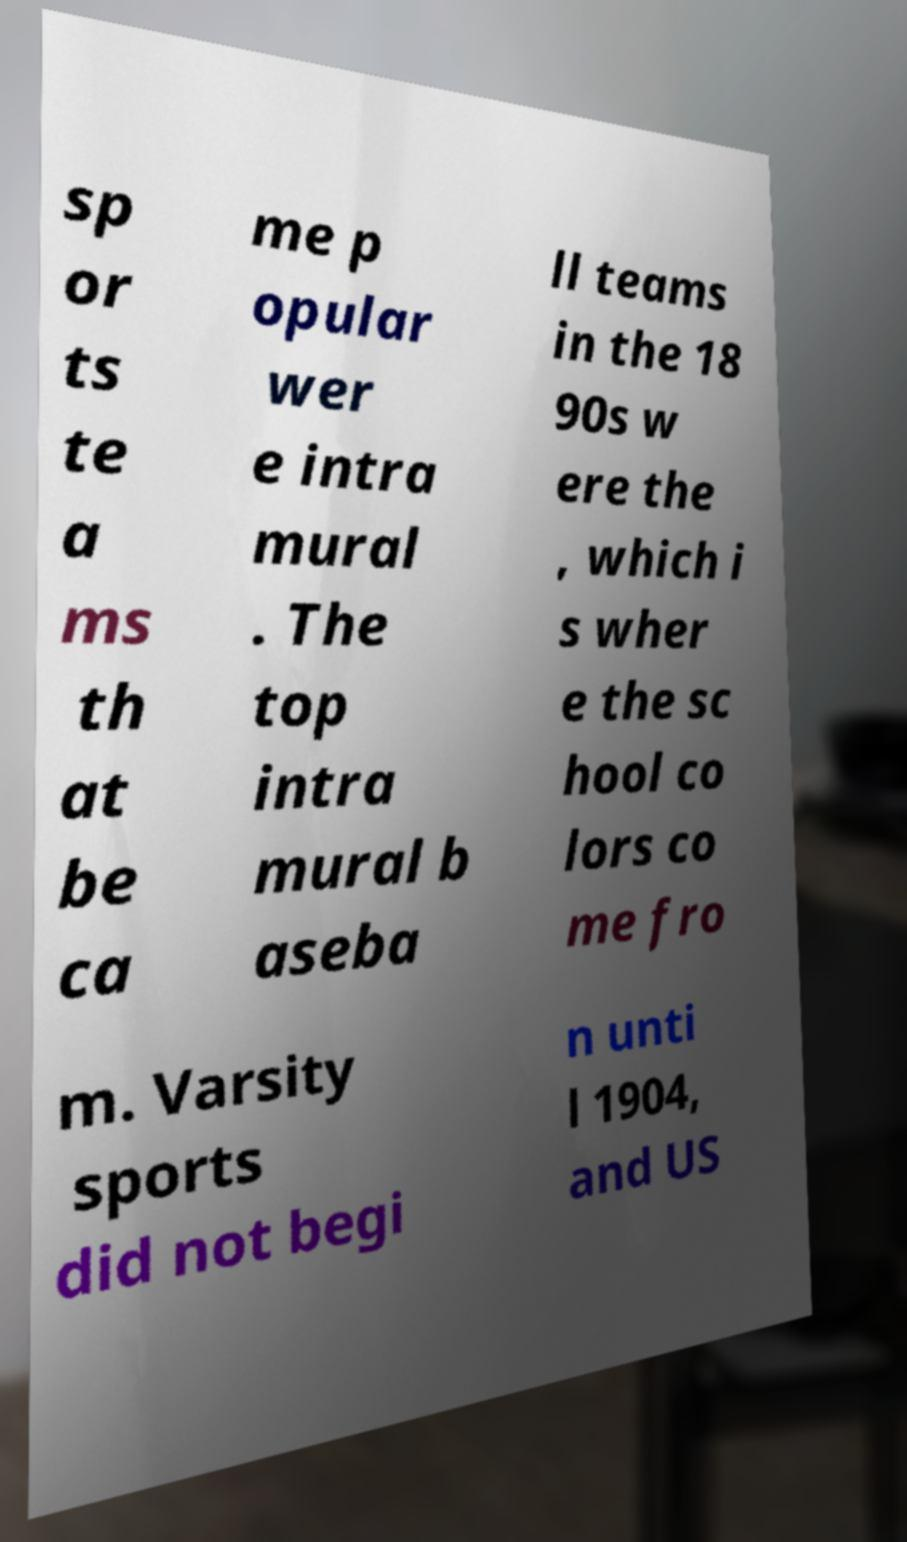I need the written content from this picture converted into text. Can you do that? sp or ts te a ms th at be ca me p opular wer e intra mural . The top intra mural b aseba ll teams in the 18 90s w ere the , which i s wher e the sc hool co lors co me fro m. Varsity sports did not begi n unti l 1904, and US 